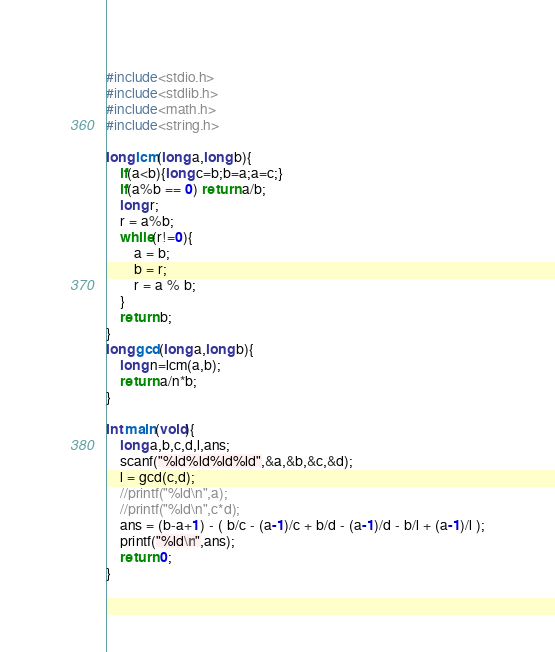<code> <loc_0><loc_0><loc_500><loc_500><_C_>#include<stdio.h>
#include<stdlib.h>
#include<math.h>
#include<string.h>

long lcm(long a,long b){
    if(a<b){long c=b;b=a;a=c;}
    if(a%b == 0) return a/b;
    long r;
    r = a%b;
    while(r!=0){
        a = b;
        b = r;
        r = a % b;
    }
    return b;
}
long gcd(long a,long b){
    long n=lcm(a,b);
    return a/n*b;
}

int main(void){
    long a,b,c,d,l,ans;
    scanf("%ld%ld%ld%ld",&a,&b,&c,&d);
    l = gcd(c,d);
    //printf("%ld\n",a);
    //printf("%ld\n",c*d);
    ans = (b-a+1) - ( b/c - (a-1)/c + b/d - (a-1)/d - b/l + (a-1)/l );
    printf("%ld\n",ans);
    return 0;
}
</code> 